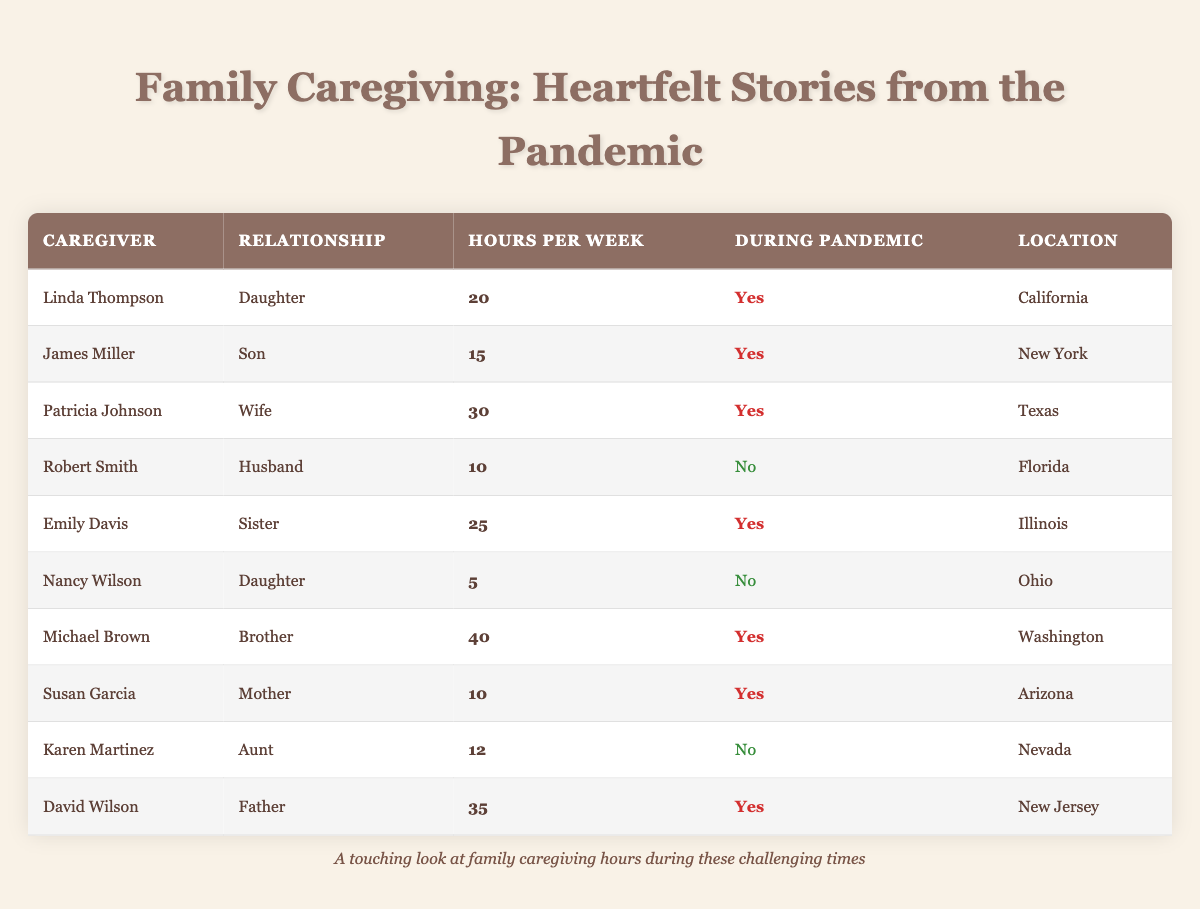What is the maximum number of caregiving hours reported during the pandemic? The table shows the caregivers who provided hours during the pandemic. The highest number of hours is listed under Michael Brown with 40 hours per week.
Answer: 40 How many different states are represented by the caregivers during the pandemic? Looking at the table, the states represented are California, New York, Texas, Illinois, Washington, Arizona, and New Jersey; that is 7 unique states.
Answer: 7 Who is the caregiver with the least hours of caregiving during the pandemic? Reviewing the table for caregivers during the pandemic, I see that Nancy Wilson has the least hours at 5 hours per week.
Answer: Nancy Wilson What is the total number of hours of caregiving from all caregivers during the pandemic? To find the total, I add the hours from each caregiver during the pandemic: 20 + 15 + 30 + 25 + 40 + 10 + 35 = 175 hours total.
Answer: 175 Which caregiver has the highest number of hours among family members who are daughters? In the table, the daughters are Linda Thompson with 20 hours and Nancy Wilson with 5 hours. Linda has the highest number at 20 hours.
Answer: Linda Thompson Is David Wilson providing caregiving hours during the pandemic? The table states that David Wilson is indeed active during the pandemic, providing 35 hours per week.
Answer: Yes What is the average hours spent by caregivers during the pandemic? Summing the hours provided during the pandemic (20, 15, 30, 25, 40, 10, 35 = 175) and dividing by the number of caregivers (7) gives an average of 25 hours per week.
Answer: 25 How many caregivers reported fewer than 15 hours per week during the pandemic? Reviewing the data, we see that only James Miller with 15 hours does not fall below 15, while Patricia Johnson, Emily Davis, Michael Brown, Linda Thompson, and Susan Garcia are above 15; therefore, only James is at that threshold.
Answer: 0 Which relationship includes the caregiver with the most hours during the pandemic? Michael Brown is the caregiver with the most hours (40), and his relationship is that of a brother.
Answer: Brother 